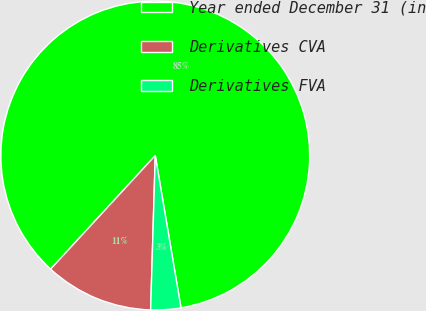Convert chart to OTSL. <chart><loc_0><loc_0><loc_500><loc_500><pie_chart><fcel>Year ended December 31 (in<fcel>Derivatives CVA<fcel>Derivatives FVA<nl><fcel>85.49%<fcel>11.37%<fcel>3.14%<nl></chart> 